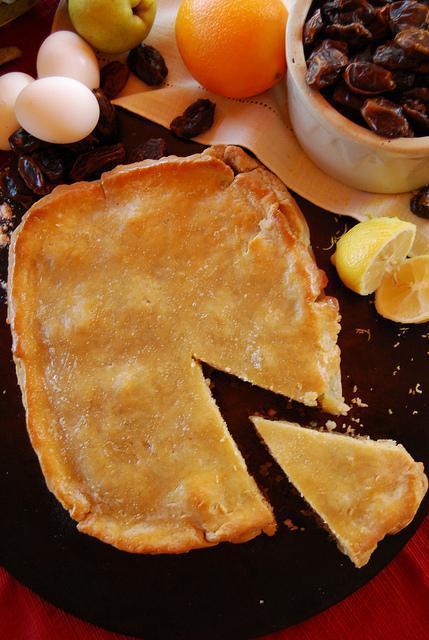Evaluate: Does the caption "The cake is on top of the apple." match the image?
Answer yes or no. No. Evaluate: Does the caption "The cake is near the apple." match the image?
Answer yes or no. Yes. 